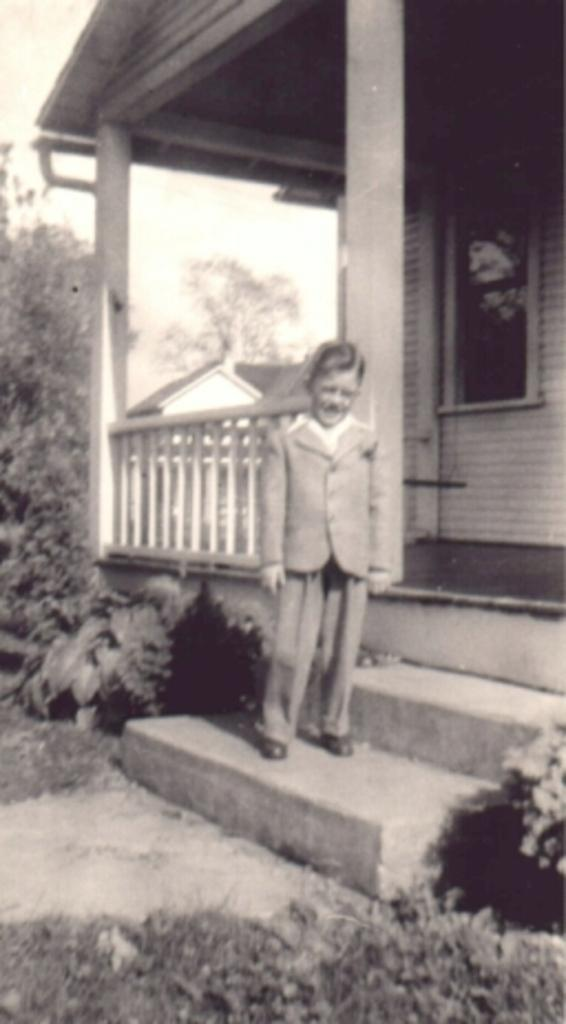What is the boy in the image doing? The boy is standing on the stairs in the image. What can be seen at the bottom of the image? There are plants at the bottom of the image. What is visible in the background of the image? There are houses, trees, and the sky visible in the background of the image. What type of fowl can be seen flying in the image? There is no fowl visible in the image; it only features a boy standing on the stairs, plants at the bottom, and houses, trees, and the sky in the background. 